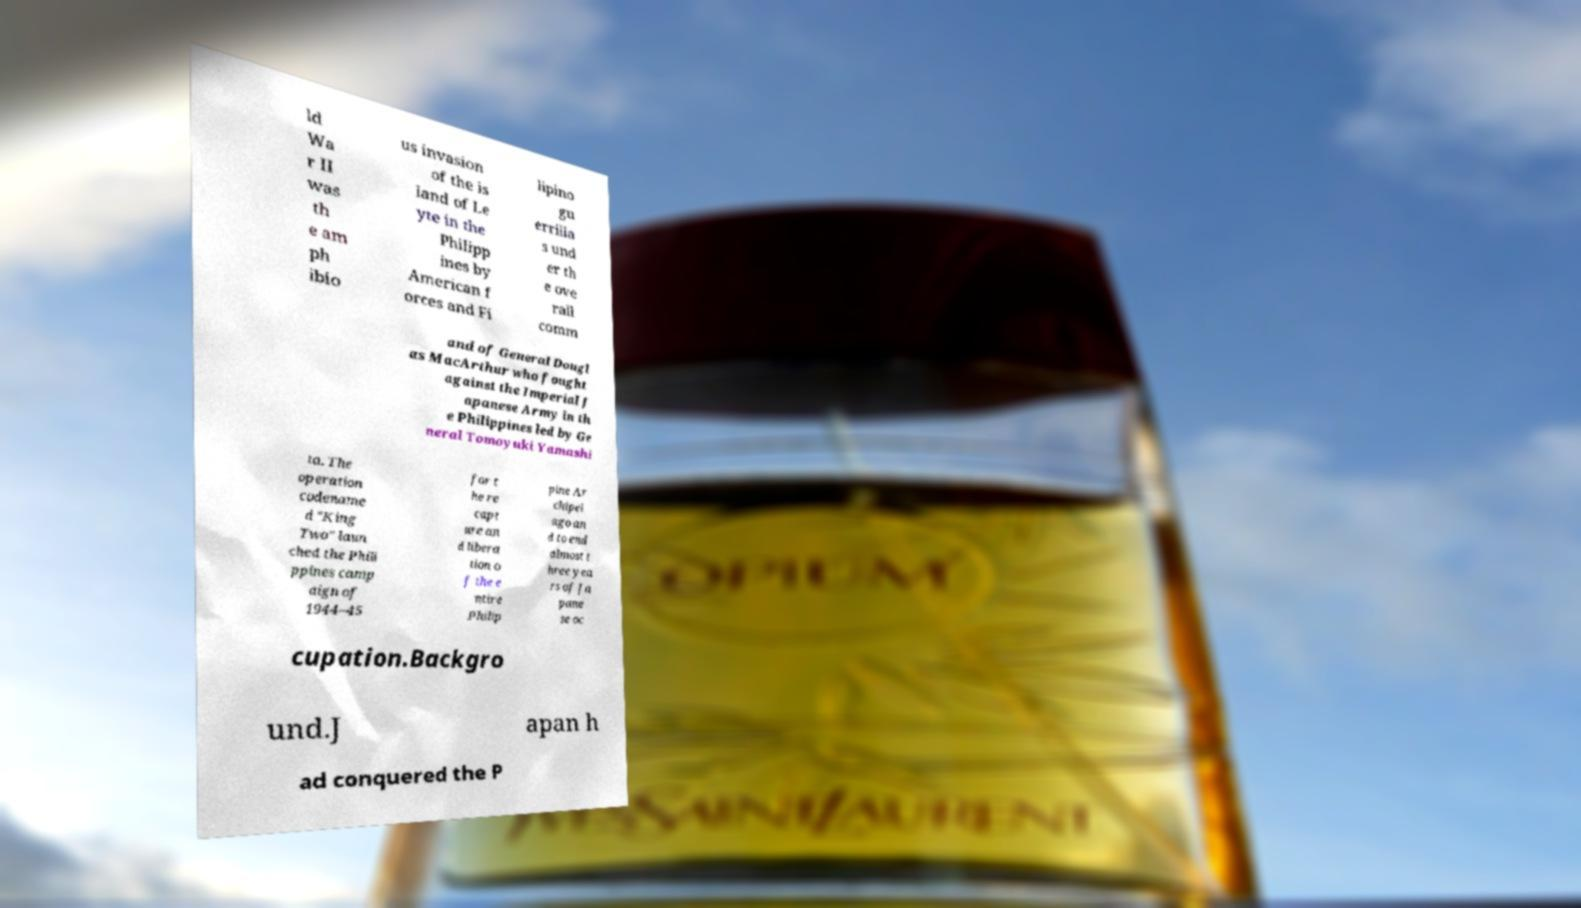There's text embedded in this image that I need extracted. Can you transcribe it verbatim? ld Wa r II was th e am ph ibio us invasion of the is land of Le yte in the Philipp ines by American f orces and Fi lipino gu errilla s und er th e ove rall comm and of General Dougl as MacArthur who fought against the Imperial J apanese Army in th e Philippines led by Ge neral Tomoyuki Yamashi ta. The operation codename d "King Two" laun ched the Phili ppines camp aign of 1944–45 for t he re capt ure an d libera tion o f the e ntire Philip pine Ar chipel ago an d to end almost t hree yea rs of Ja pane se oc cupation.Backgro und.J apan h ad conquered the P 